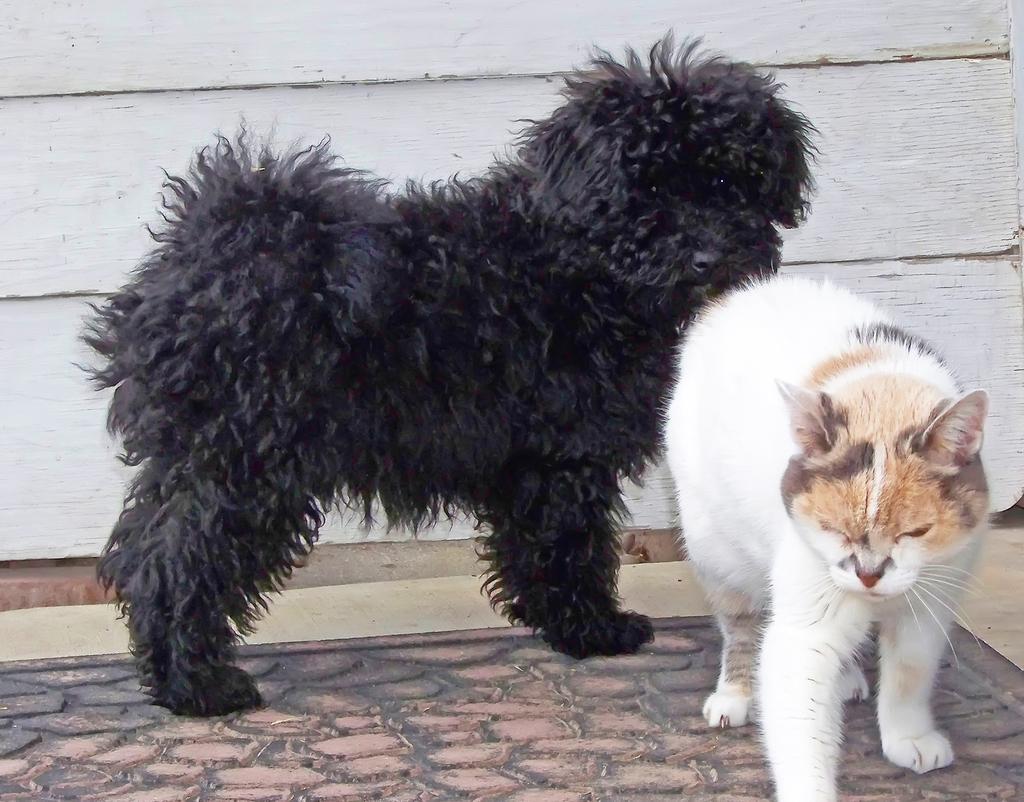How would you summarize this image in a sentence or two? In this image we can see a dog and a cat standing on the floor. In the background there is a wall. 